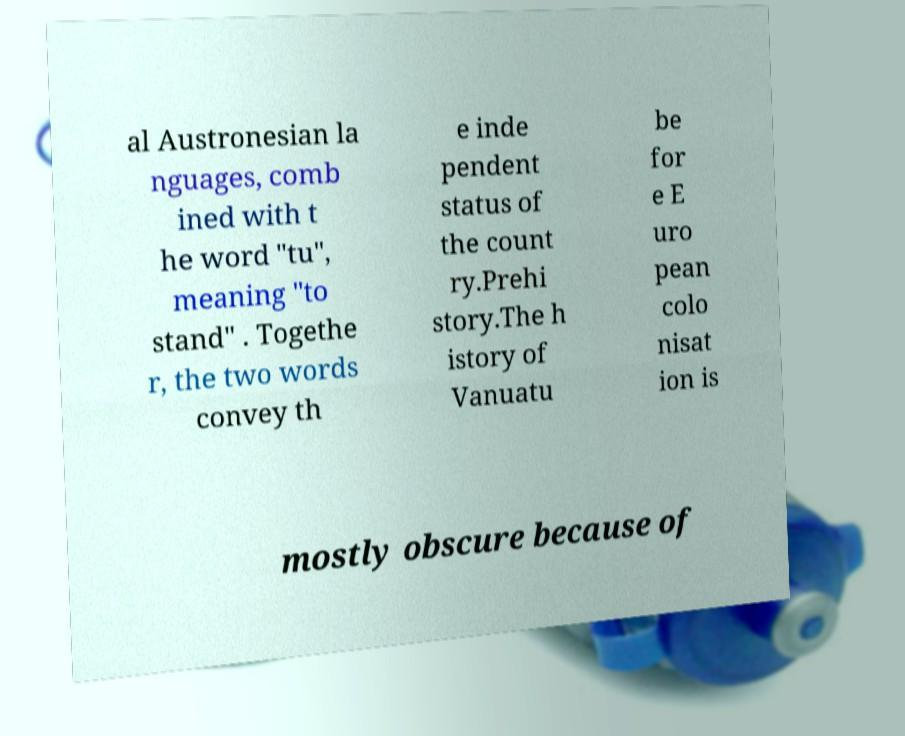There's text embedded in this image that I need extracted. Can you transcribe it verbatim? al Austronesian la nguages, comb ined with t he word "tu", meaning "to stand" . Togethe r, the two words convey th e inde pendent status of the count ry.Prehi story.The h istory of Vanuatu be for e E uro pean colo nisat ion is mostly obscure because of 